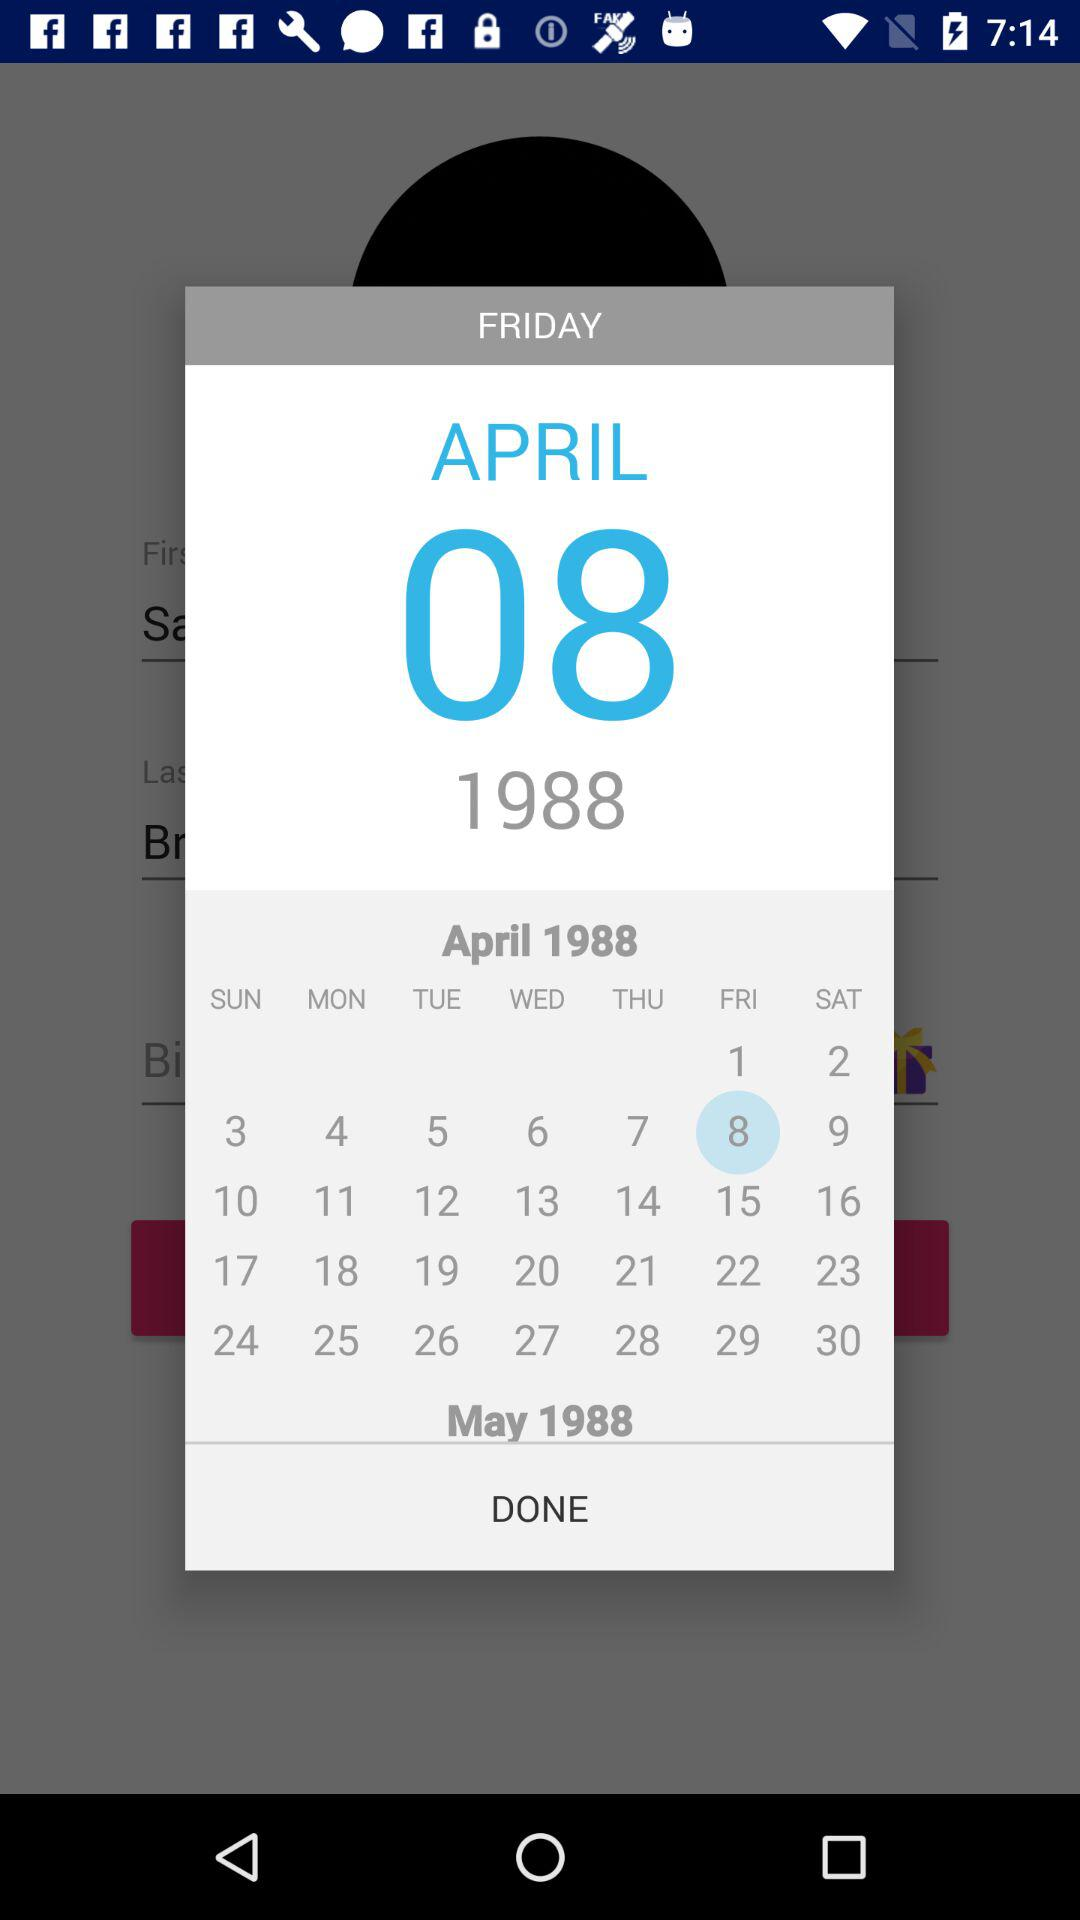Which day falls on May 1, 1988?
When the provided information is insufficient, respond with <no answer>. <no answer> 